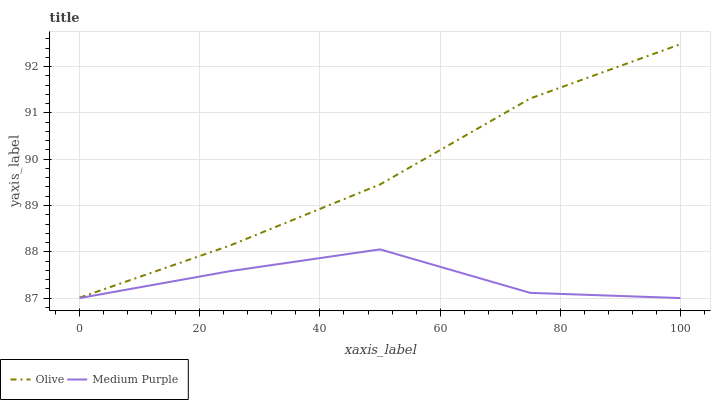Does Medium Purple have the minimum area under the curve?
Answer yes or no. Yes. Does Olive have the maximum area under the curve?
Answer yes or no. Yes. Does Medium Purple have the maximum area under the curve?
Answer yes or no. No. Is Olive the smoothest?
Answer yes or no. Yes. Is Medium Purple the roughest?
Answer yes or no. Yes. Is Medium Purple the smoothest?
Answer yes or no. No. Does Medium Purple have the lowest value?
Answer yes or no. Yes. Does Olive have the highest value?
Answer yes or no. Yes. Does Medium Purple have the highest value?
Answer yes or no. No. Is Medium Purple less than Olive?
Answer yes or no. Yes. Is Olive greater than Medium Purple?
Answer yes or no. Yes. Does Medium Purple intersect Olive?
Answer yes or no. No. 